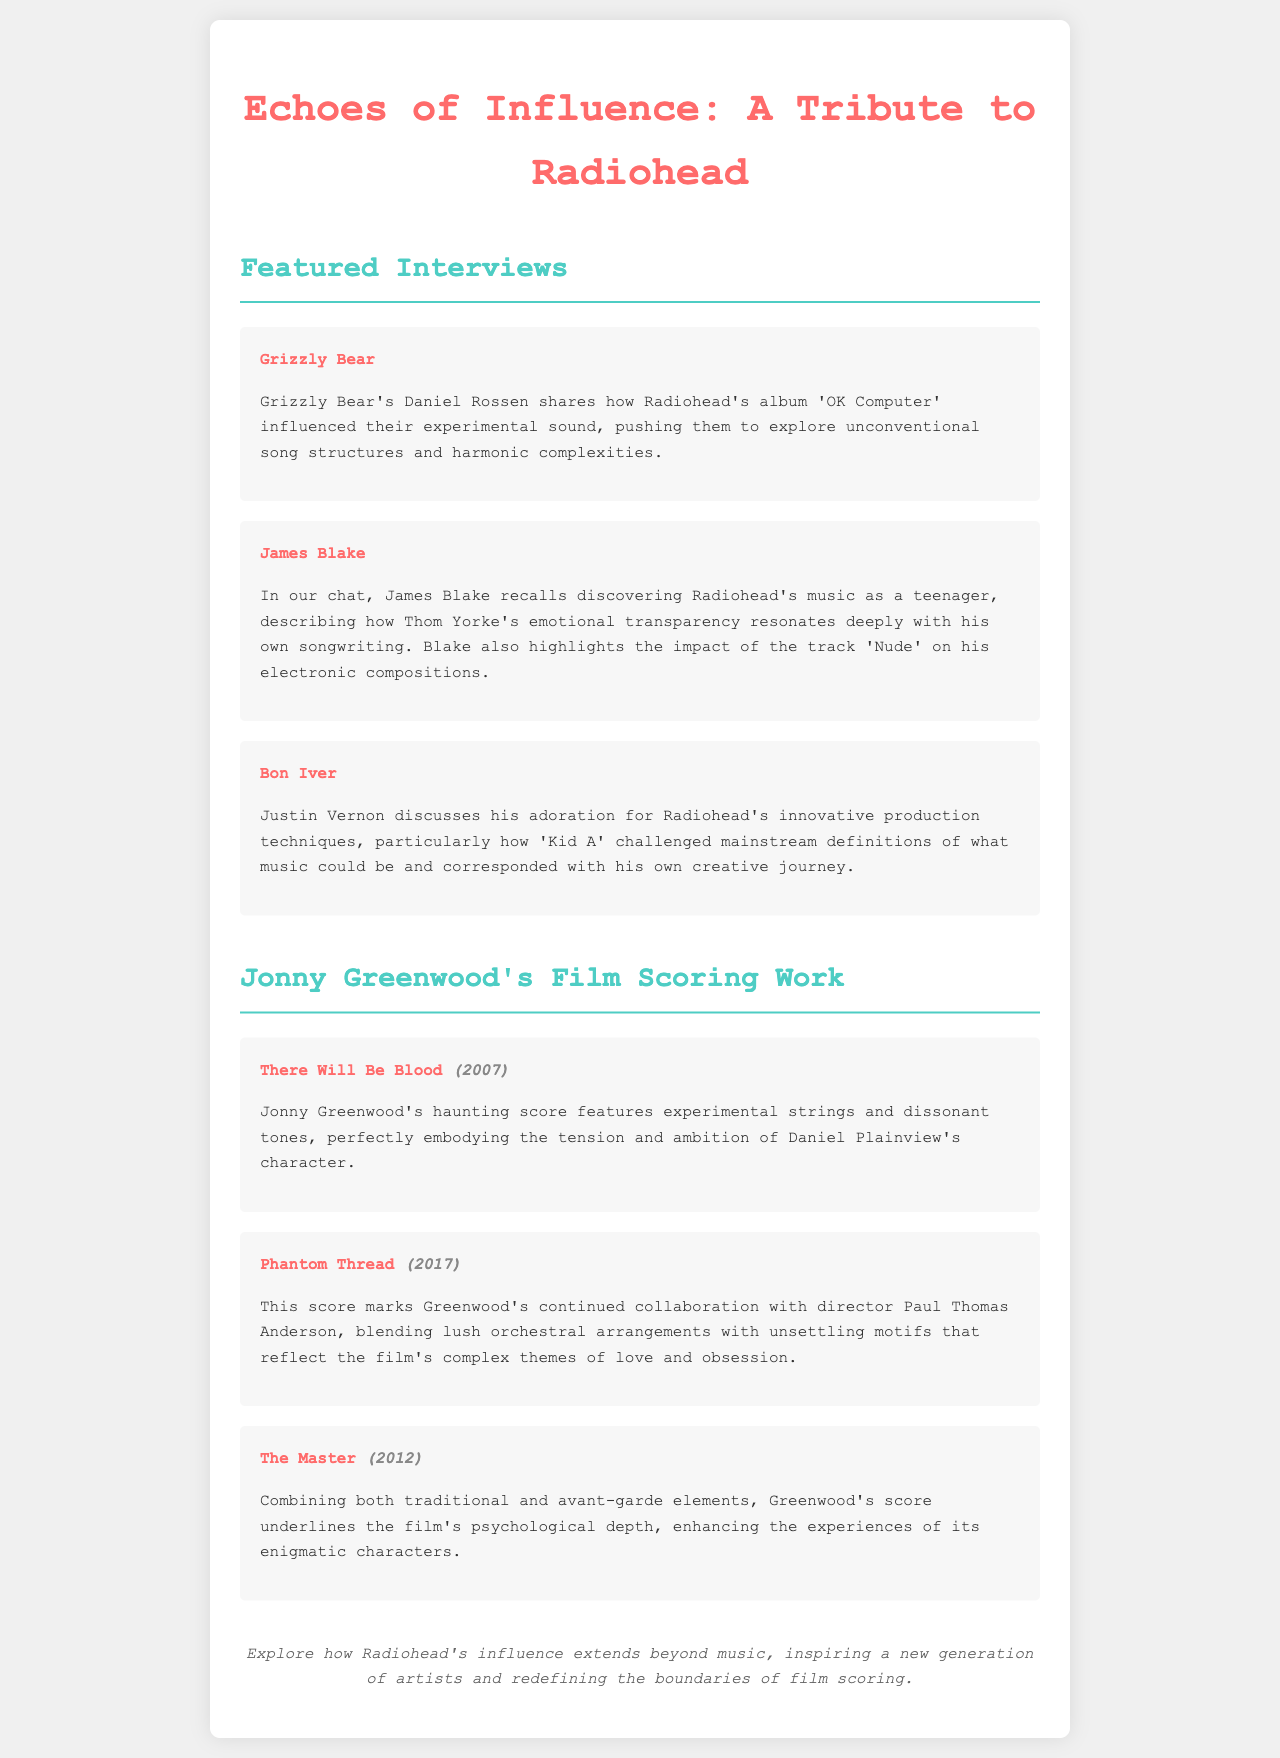What is the title of the magazine? The title of the magazine is prominently displayed at the top of the document as the main heading.
Answer: Echoes of Influence: A Tribute to Radiohead Who is interviewed from Grizzly Bear? The document specifies the artist interviewed from Grizzly Bear, indicated in the featured interviews section.
Answer: Daniel Rossen Which track from Radiohead does James Blake mention? The interview with James Blake refers to a specific track that had a significant impact on his compositions.
Answer: Nude What year was "There Will Be Blood" released? The document includes the release year next to the film title in the film scoring section.
Answer: 2007 What type of arrangements are used in "Phantom Thread"? The description of the score for "Phantom Thread" highlights a particular musical style employed by Greenwood.
Answer: Lush orchestral arrangements How many films are mentioned in the film scoring section? The total number of films in the film scoring section can be counted from the entries listed under Jonny Greenwood's work.
Answer: Three What does the closing note encourage the reader to explore? The closing note summarizes the overarching theme of Radiohead's influence beyond music, as mentioned in the document.
Answer: How Radiohead's influence extends beyond music What is the name of the director Greenwood collaborated with for multiple scores? The document mentions the director associated with Greenwood's film scores, highlighting a professional relationship.
Answer: Paul Thomas Anderson 